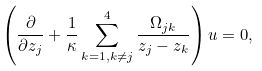Convert formula to latex. <formula><loc_0><loc_0><loc_500><loc_500>\left ( \frac { \partial } { \partial z _ { j } } + \frac { 1 } { \kappa } \sum _ { k = 1 , k \neq j } ^ { 4 } \frac { \Omega _ { j k } } { z _ { j } - z _ { k } } \right ) u = 0 ,</formula> 